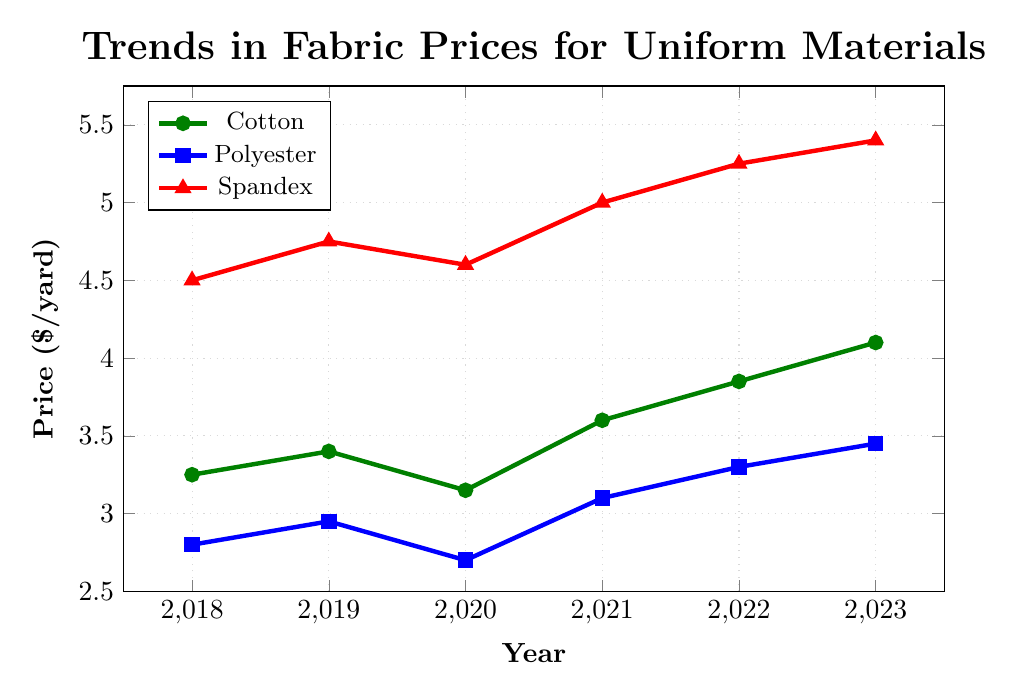What's the trend for cotton prices from 2018 to 2023? From the figure, we see cotton prices steadily increase over the years. Starting at $3.25/yard in 2018, the price goes up to $4.10/yard in 2023.
Answer: Increasing Which material had the highest price hike from 2020 to 2021? The price increase for cotton from 2020 to 2021 is $3.60 - $3.15 = $0.45. For polyester, it's $3.10 - $2.70 = $0.40. For spandex, it's $5.00 - $4.60 = $0.40. Therefore, cotton experienced the highest price hike.
Answer: Cotton Between cotton and polyester, which had a lower price in 2020, and by how much? The price of cotton in 2020 is $3.15/yard, and the price of polyester is $2.70/yard. The difference is $3.15 - $2.70 = $0.45. Cotton had a higher price than polyester in 2020 by $0.45.
Answer: Polyester, $0.45 What is the average price of spandex over the 5 years depicted? Sum the prices of spandex from 2018 to 2023: $4.50 + $4.75 + $4.60 + $5.00 + $5.25 + $5.40 = $29.50. The average is $29.50 / 6 = $4.92.
Answer: $4.92 Which fabric shows the most consistent price increase year over year? To identify consistent increases, examine the year-over-year price changes:
- Cotton: $3.25, $3.40, $3.15, $3.60, $3.85, $4.10. Shows a dip from 2019 to 2020.
- Polyester: $2.80, $2.95, $2.70, $3.10, $3.30, $3.45. Shows a dip from 2019 to 2020.
- Spandex: $4.50, $4.75, $4.60, $5.00, $5.25, $5.40. Shows a dip from 2019 to 2020.
Since no fabric consistently increases without any dips, no fabric qualifies as most consistent in this regard.
Answer: None What is the percentage increase in the price of polyester from 2018 to 2023? The price of polyester in 2018 is $2.80/yard and in 2023 is $3.45/yard. The increase is $3.45 - $2.80 = $0.65. The percentage increase is ($0.65 / $2.80) * 100 = 23.21%.
Answer: 23.21% How do the trends for polyester and cotton compare between 2018 and 2023? Both polyester and cotton show an increasing trend from 2018 to 2023. Cotton rises from $3.25 to $4.10, while polyester rises from $2.80 to $3.45. Both trends suggest a steady increase over the years with minor fluctuations.
Answer: Both show an increasing trend Which year saw the highest price for spandex? From the figure, the price of spandex increases each year, reaching its highest point at $5.40/yard in 2023.
Answer: 2023 